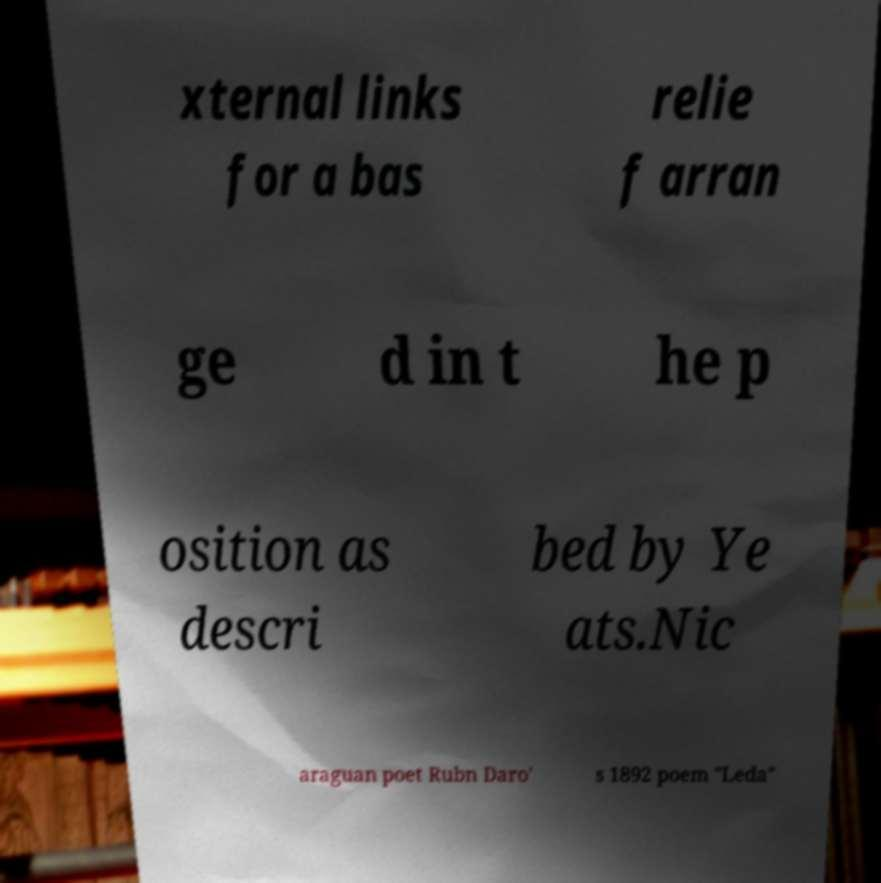Could you extract and type out the text from this image? xternal links for a bas relie f arran ge d in t he p osition as descri bed by Ye ats.Nic araguan poet Rubn Daro' s 1892 poem "Leda" 